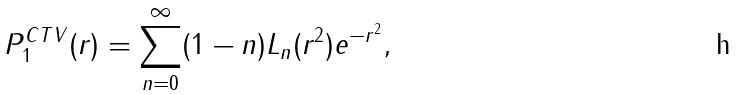<formula> <loc_0><loc_0><loc_500><loc_500>P ^ { C T V } _ { 1 } ( r ) = \sum ^ { \infty } _ { n = 0 } ( 1 - n ) L _ { n } ( r ^ { 2 } ) e ^ { - r ^ { 2 } } ,</formula> 